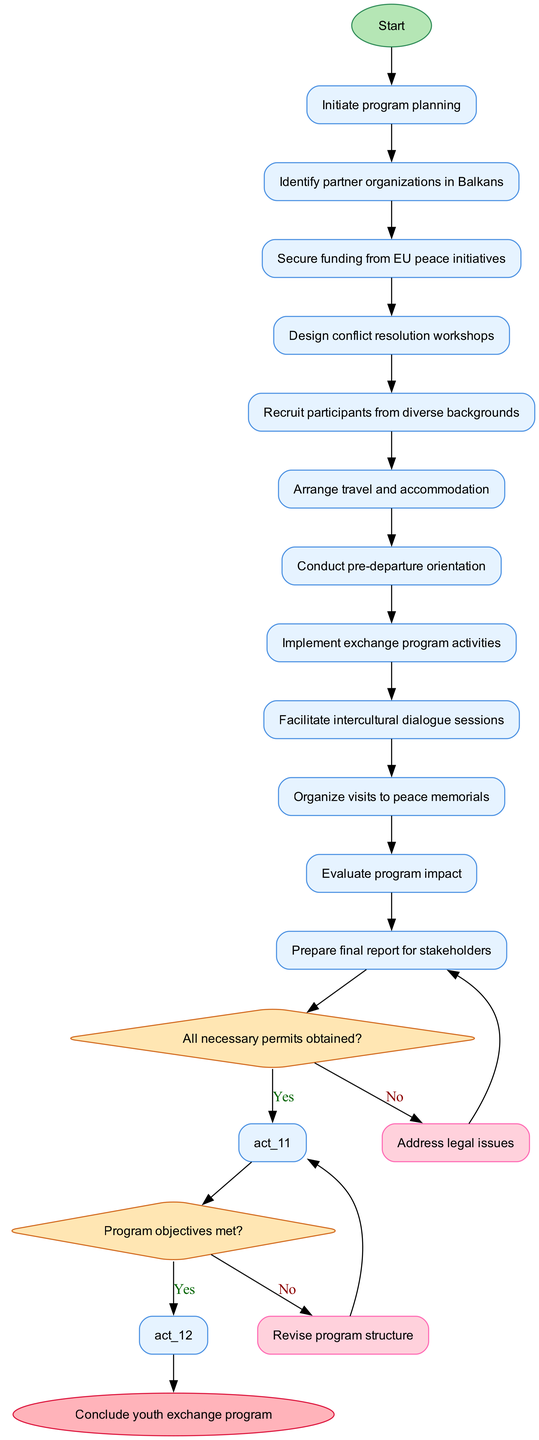What is the first activity in the diagram? The first activity listed in the diagram is "Identify partner organizations in Balkans," which follows the starting node "Initiate program planning."
Answer: Identify partner organizations in Balkans How many activities are in total? There are 11 activities listed in the diagram, as evidenced by the count of the items in the activities section.
Answer: 11 What decision is made after conducting pre-departure orientation? After conducting pre-departure orientation, the next node is a decision point where the condition is "All necessary permits obtained?" This is the next action in the flow based on completion of this activity.
Answer: All necessary permits obtained? If the program objectives are not met, what action is taken? According to the diagram, if the program objectives are not met, the flow leads to "Revise program structure," which is specified as an alternative path from the decision node.
Answer: Revise program structure How many decision nodes are in the diagram? The diagram contains 2 decision nodes, as can be seen in the decisionNodes section, each representing a distinct condition that influences the flow of activities.
Answer: 2 What is the final action before the program concludes? The final action before concluding the program is "Prepare final report for stakeholders," which follows the decision node related to whether program objectives are met.
Answer: Prepare final report for stakeholders What happens if necessary permits are not obtained? If necessary permits are not obtained, the flow of activities indicates that it leads to "Address legal issues," which is an alternative response from the first decision node.
Answer: Address legal issues How many activities lead directly to the evaluation of program impact? "Evaluate program impact" is the last activity leading to the end node of the diagram, and it follows directly from the implementation of the exchange program activities. Therefore, there is 1 activity that leads directly to the evaluation.
Answer: 1 